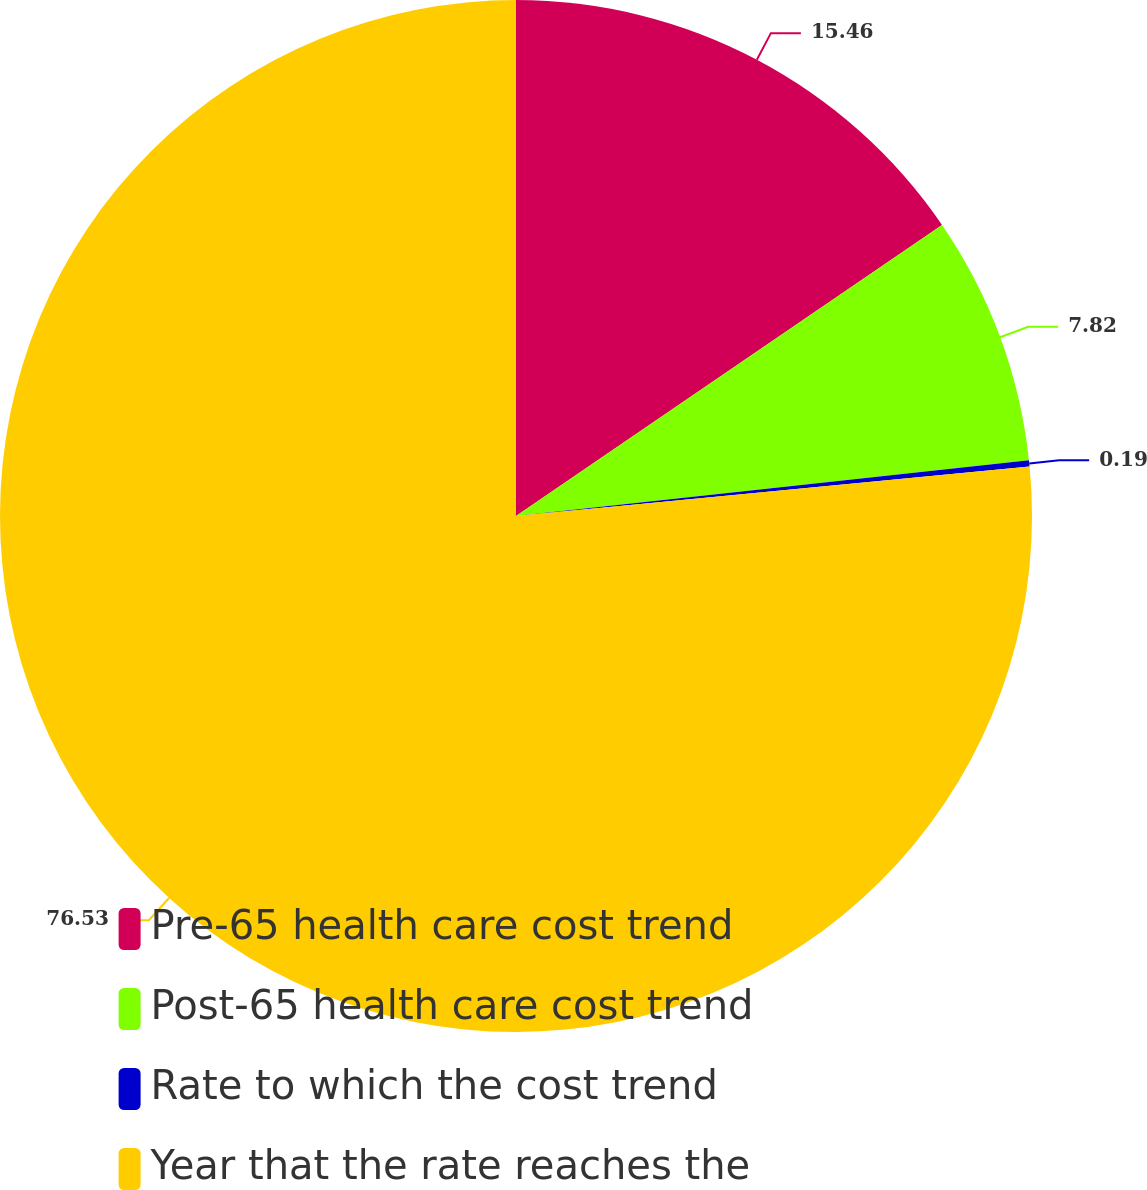Convert chart. <chart><loc_0><loc_0><loc_500><loc_500><pie_chart><fcel>Pre-65 health care cost trend<fcel>Post-65 health care cost trend<fcel>Rate to which the cost trend<fcel>Year that the rate reaches the<nl><fcel>15.46%<fcel>7.82%<fcel>0.19%<fcel>76.53%<nl></chart> 